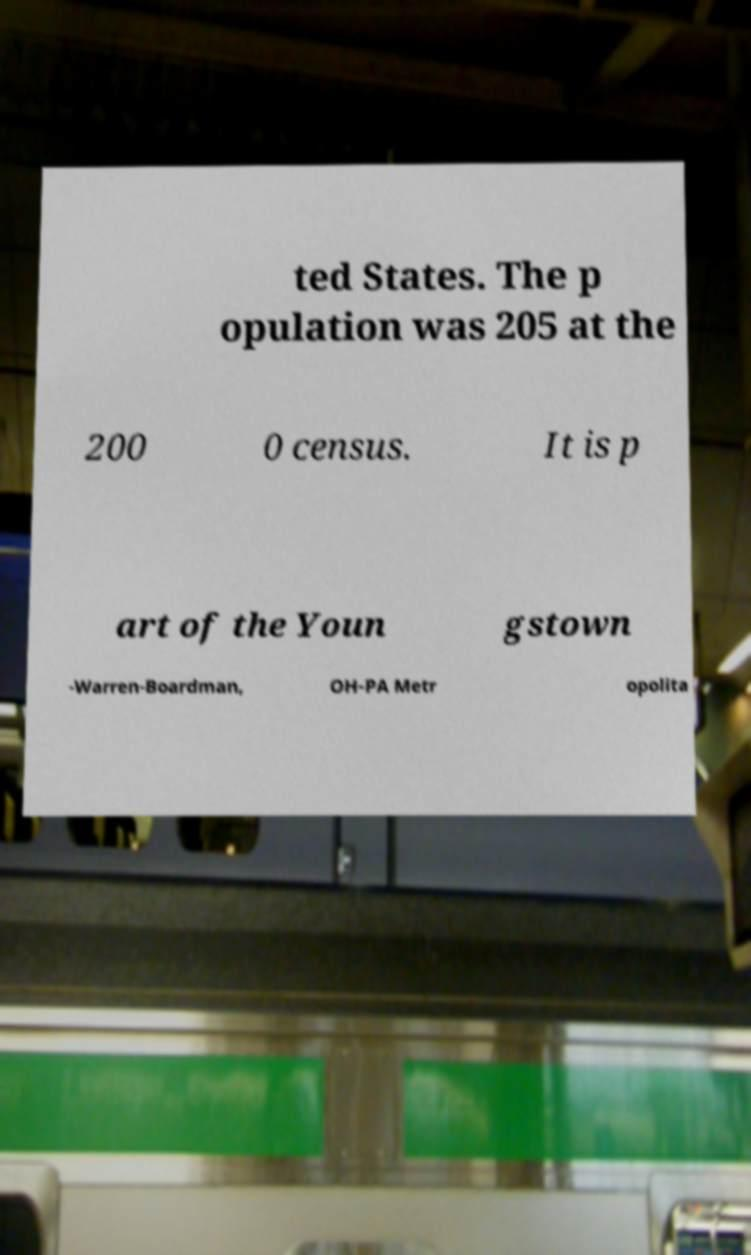Could you assist in decoding the text presented in this image and type it out clearly? ted States. The p opulation was 205 at the 200 0 census. It is p art of the Youn gstown -Warren-Boardman, OH-PA Metr opolita 